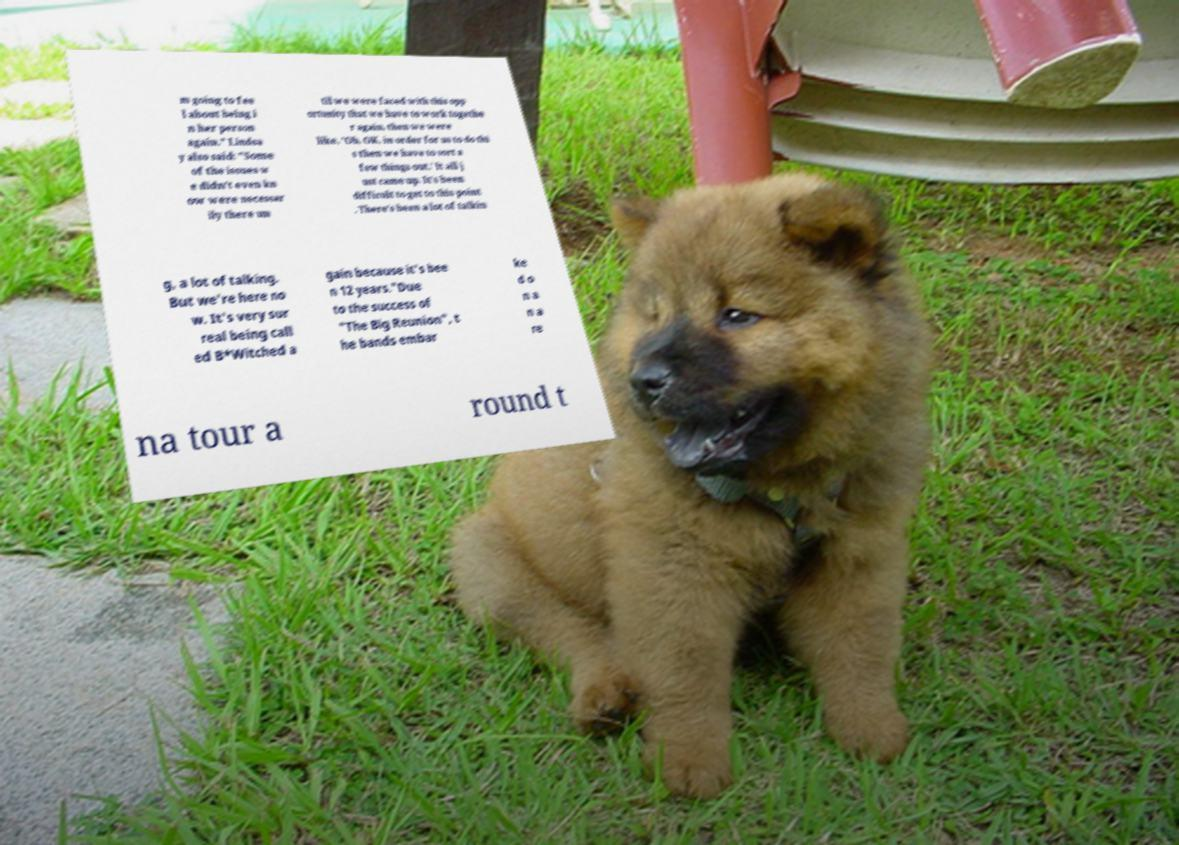For documentation purposes, I need the text within this image transcribed. Could you provide that? m going to fee l about being i n her person again." Lindsa y also said: "Some of the issues w e didn't even kn ow were necessar ily there un til we were faced with this opp ortunity that we have to work togethe r again, then we were like, 'Oh, OK, in order for us to do thi s then we have to sort a few things out.' It all j ust came up. It's been difficult to get to this point . There's been a lot of talkin g, a lot of talking. But we're here no w. It's very sur real being call ed B*Witched a gain because it's bee n 12 years."Due to the success of "The Big Reunion", t he bands embar ke d o n a n a re na tour a round t 